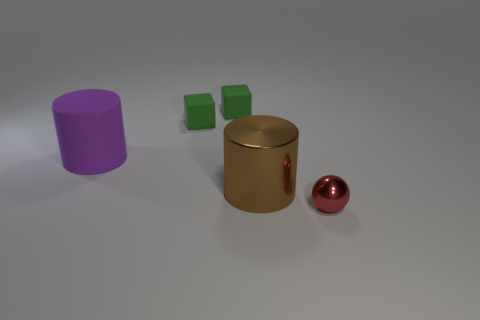Add 4 purple cylinders. How many objects exist? 9 Subtract all spheres. How many objects are left? 4 Add 3 blue cylinders. How many blue cylinders exist? 3 Subtract 0 brown spheres. How many objects are left? 5 Subtract all tiny red objects. Subtract all small shiny spheres. How many objects are left? 3 Add 1 brown metal cylinders. How many brown metal cylinders are left? 2 